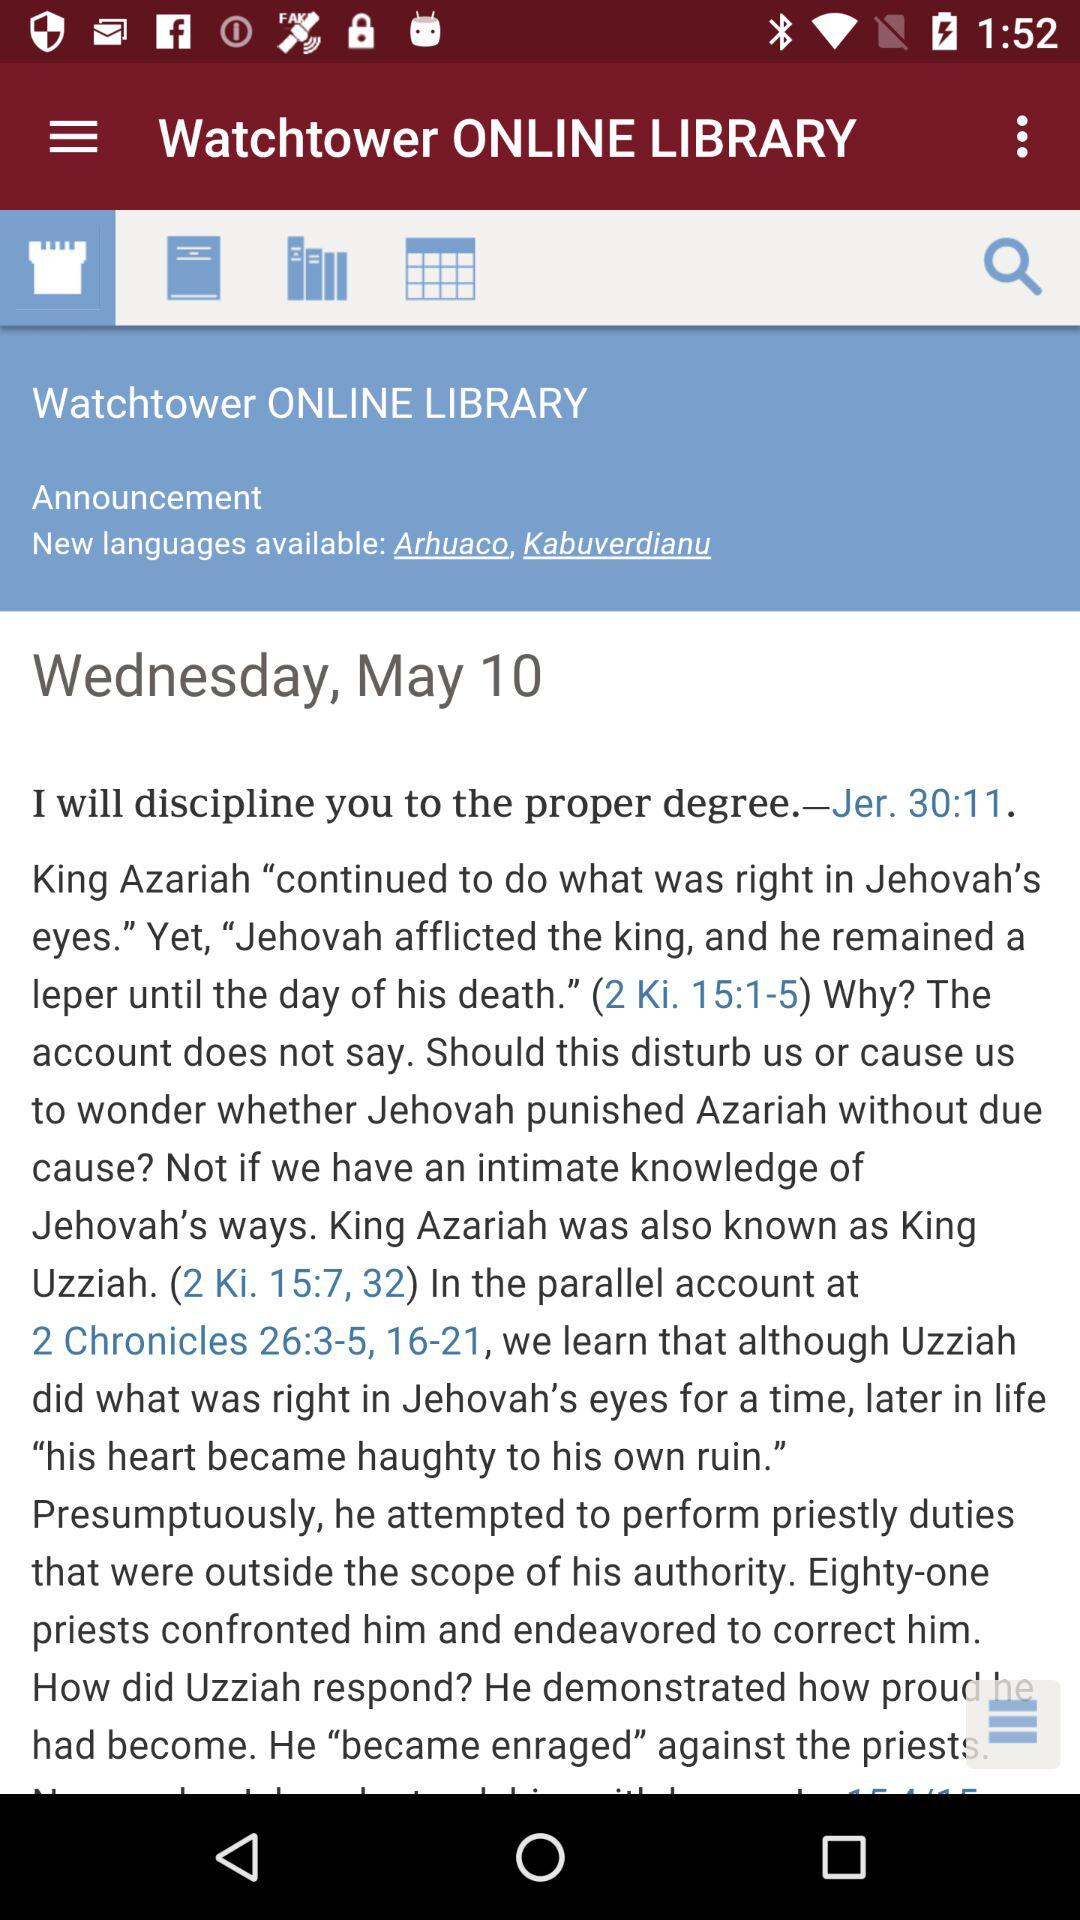What is the mentioned date? The mentioned date is Wednesday, May 10. 